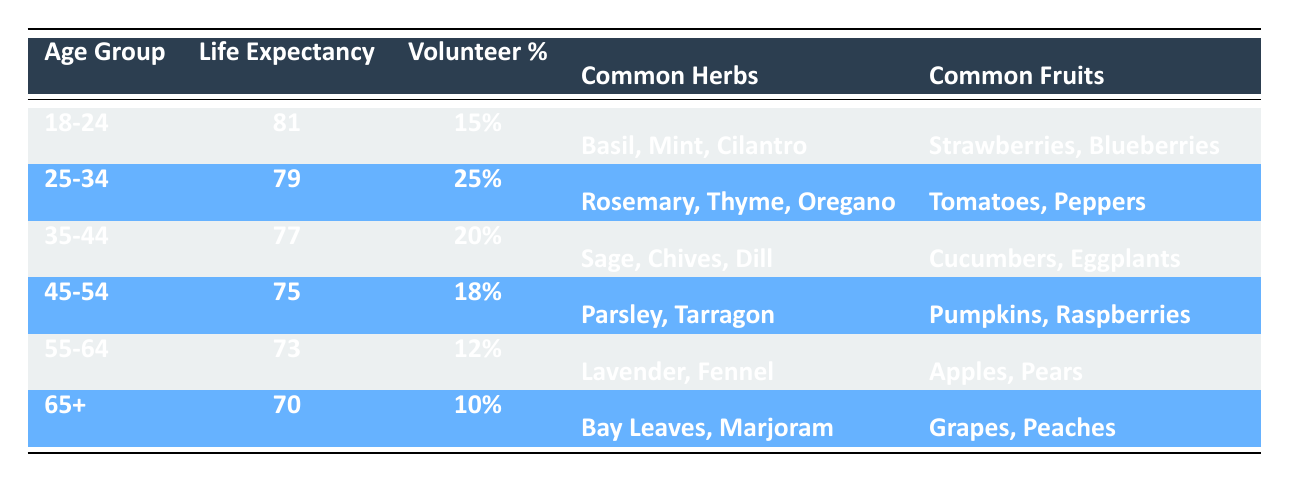What is the life expectancy of volunteers aged 45-54? The table shows the life expectancy for each age group. For the age group 45-54, the life expectancy is listed as 75.
Answer: 75 Which age group has the highest percentage of volunteers? By looking at the volunteer percentage for each age group, the 25-34 age group has the highest percentage at 25%.
Answer: 25% Is the life expectancy of volunteers aged 55-64 greater than that of those aged 65 and older? The life expectancy for the 55-64 age group is 73, while for the 65+ age group, it is 70. Since 73 is greater than 70, the statement is true.
Answer: Yes What are the common fruits for volunteers aged 35-44? The common fruits listed for the age group 35-44 in the table are Cucumbers and Eggplants.
Answer: Cucumbers, Eggplants If we average the life expectancy of the age groups 25-34 and 35-44, what is the result? The life expectancy for the 25-34 group is 79 and for the 35-44 group is 77. To find the average, we add these two values: 79 + 77 = 156, and then divide by 2, resulting in 156/2 = 78.
Answer: 78 What common herbs are associated with volunteers aged 18-24? For the 18-24 age group, the common herbs listed in the table are Basil, Mint, and Cilantro.
Answer: Basil, Mint, Cilantro Does the age group 55-64 have a higher volunteer percentage than the age group 45-54? The volunteer percentage for 55-64 is 12%, while for 45-54 it is 18%. Since 12% is less than 18%, this statement is false.
Answer: No What is the difference in life expectancy between the youngest (18-24) and oldest age group (65+)? The life expectancy for 18-24 is 81 and for 65+ is 70. The difference is calculated by subtracting: 81 - 70 = 11.
Answer: 11 Which age group has the least variety of common fruits listed? The age group 65+ has common fruits listed as Grapes and Peaches, which is fewer in variety compared to other age groups.
Answer: 65+ Are the common herbs for volunteers aged 25-34 different from those for volunteers aged 45-54? The common herbs for 25-34 are Rosemary, Thyme, and Oregano, while for 45-54 they are Parsley and Tarragon. Since the herbs differ between these two age groups, this statement is true.
Answer: Yes 